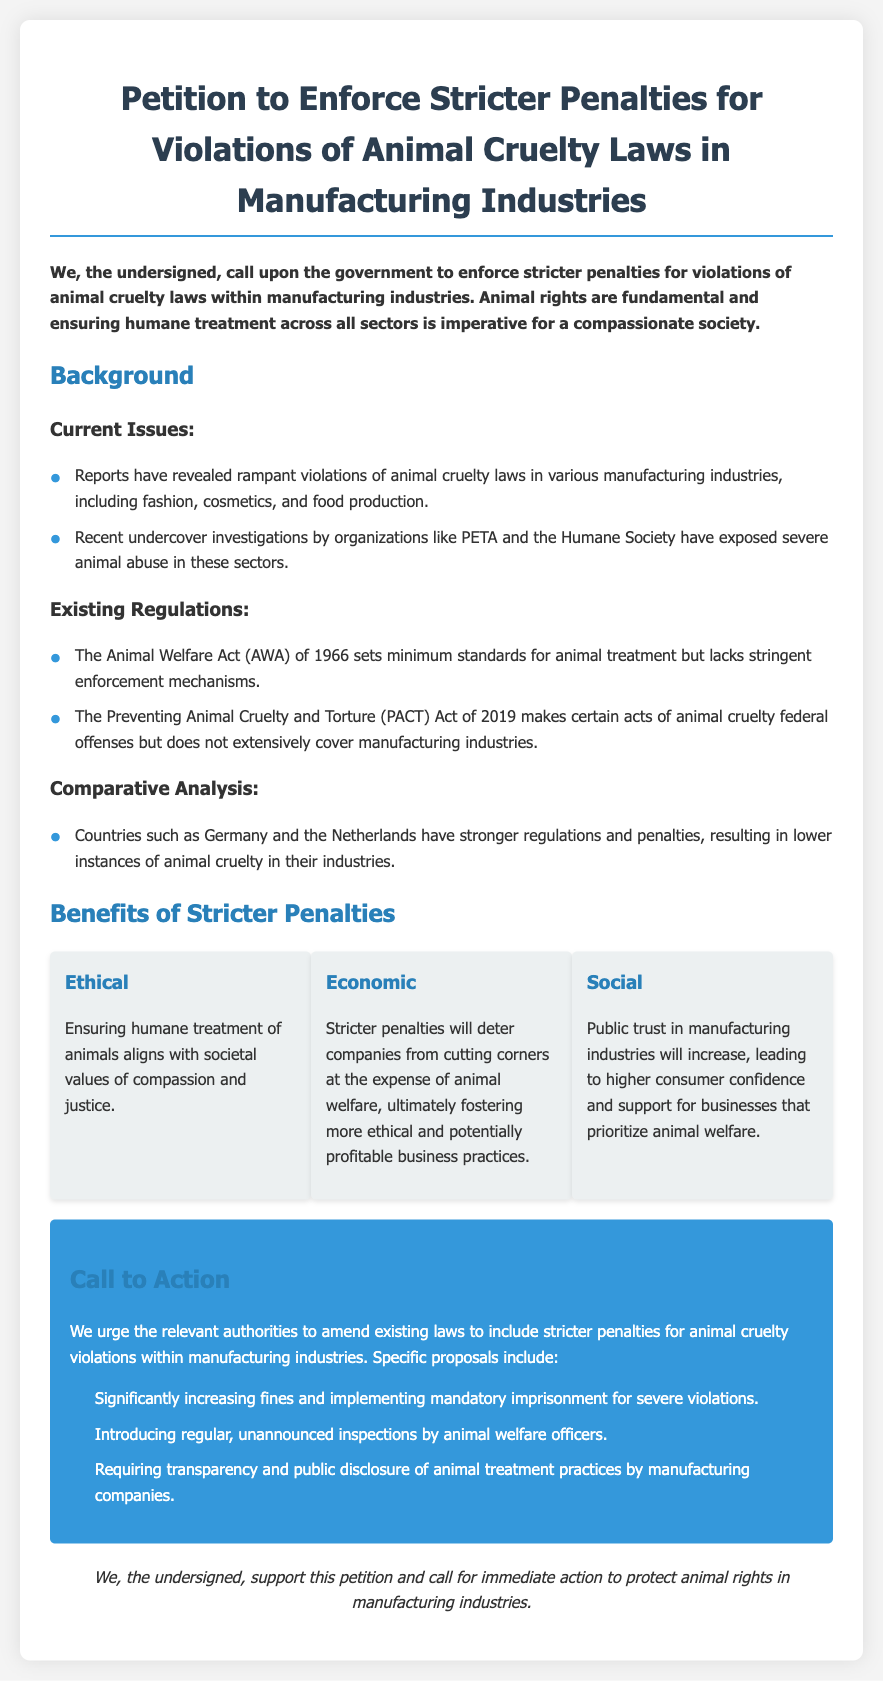what is the title of the petition? The title of the petition is prominently displayed at the top of the document.
Answer: Petition to Enforce Stricter Penalties for Violations of Animal Cruelty Laws in Manufacturing Industries what year was the Preventing Animal Cruelty and Torture Act enacted? The document mentions the enactment year of the PACT Act in the existing regulations section.
Answer: 2019 what are the three proposed actions in the call to action? The document outlines specific proposals for action in the call to action section.
Answer: Increasing fines, unannounced inspections, transparency requirements which countries are mentioned as having stronger regulations? The comparative analysis section highlights countries with better animal cruelty regulations.
Answer: Germany and the Netherlands what does the ethical benefit emphasize? The ethical benefit section discusses the importance of humane treatment in line with societal values.
Answer: Compassion and justice how many signatories support the petition? The document states that the support for the petition comes from the undersigned but does not specify a number.
Answer: Not specified what is the main focus of the petition? The core objective is clearly articulated at the beginning of the document.
Answer: Stricter penalties for animal cruelty violations what should be increased for severe violations according to the call to action? The document specifies measures to be taken for severe violations in the call to action section.
Answer: Fines and mandatory imprisonment 